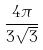<formula> <loc_0><loc_0><loc_500><loc_500>\frac { 4 \pi } { 3 \sqrt { 3 } }</formula> 